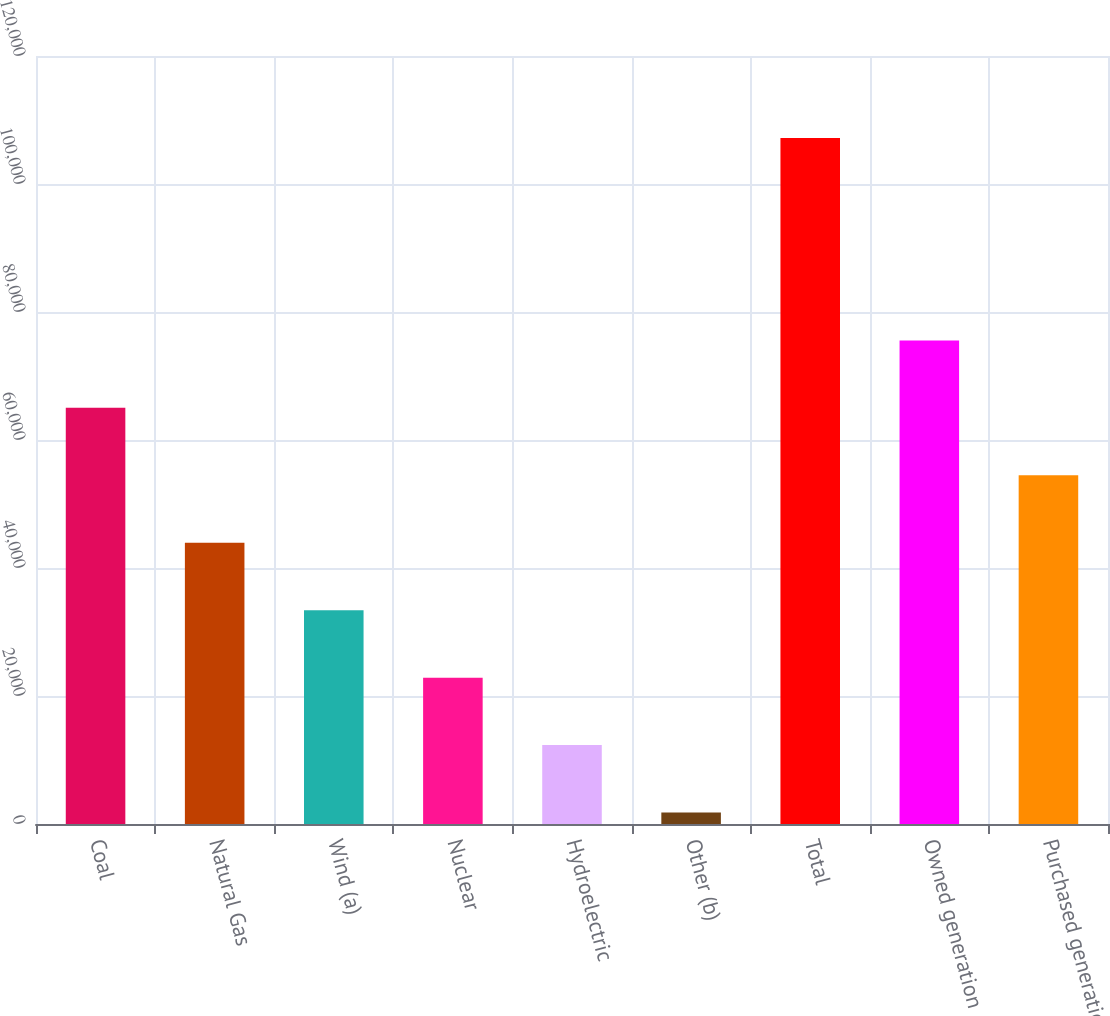Convert chart to OTSL. <chart><loc_0><loc_0><loc_500><loc_500><bar_chart><fcel>Coal<fcel>Natural Gas<fcel>Wind (a)<fcel>Nuclear<fcel>Hydroelectric<fcel>Other (b)<fcel>Total<fcel>Owned generation<fcel>Purchased generation<nl><fcel>65021.8<fcel>43946.2<fcel>33408.4<fcel>22870.6<fcel>12332.8<fcel>1795<fcel>107173<fcel>75559.6<fcel>54484<nl></chart> 